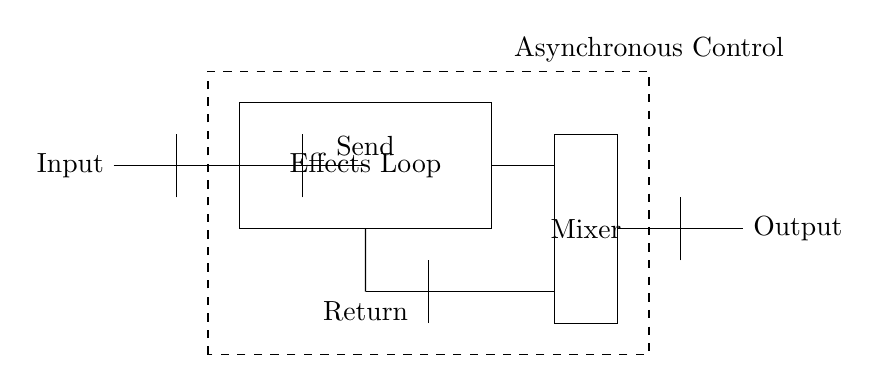What is the input of the circuit? The input is located at the leftmost position in the diagram and is labeled as "Input."
Answer: Input What is the function of the buffer in this circuit? The buffer amplifies the signal and isolates the input and output, preventing loading effects on the circuit.
Answer: Amplification What does the dashed rectangle represent? The dashed rectangle labeled "Asynchronous Control" signifies a section for controlling the audio effects loop without synchronous timing.
Answer: Asynchronous Control How many buffers are present in the diagram? By counting the symbols labeled as buffers, there are four buffer components in the circuit.
Answer: Four What is the label on the effects loop section? The effects loop is enclosed in a rectangle that centrally displays the label "Effects Loop."
Answer: Effects Loop What is the purpose of the "Mixer" in this circuit? The mixer combines multiple input signals into a single output signal, adjusting levels as needed.
Answer: Combining signals What are the two main pathways in the effects loop segment? The effects loop has a "Send" pathway for sending the signal out and a "Return" pathway to bring it back into the circuit.
Answer: Send and Return 